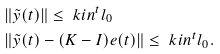<formula> <loc_0><loc_0><loc_500><loc_500>& \| \tilde { y } ( t ) \| \leq \ k i n ^ { t } l _ { 0 } \\ & \| \tilde { y } ( t ) - ( K - I ) e ( t ) \| \leq \ k i n ^ { t } l _ { 0 } .</formula> 